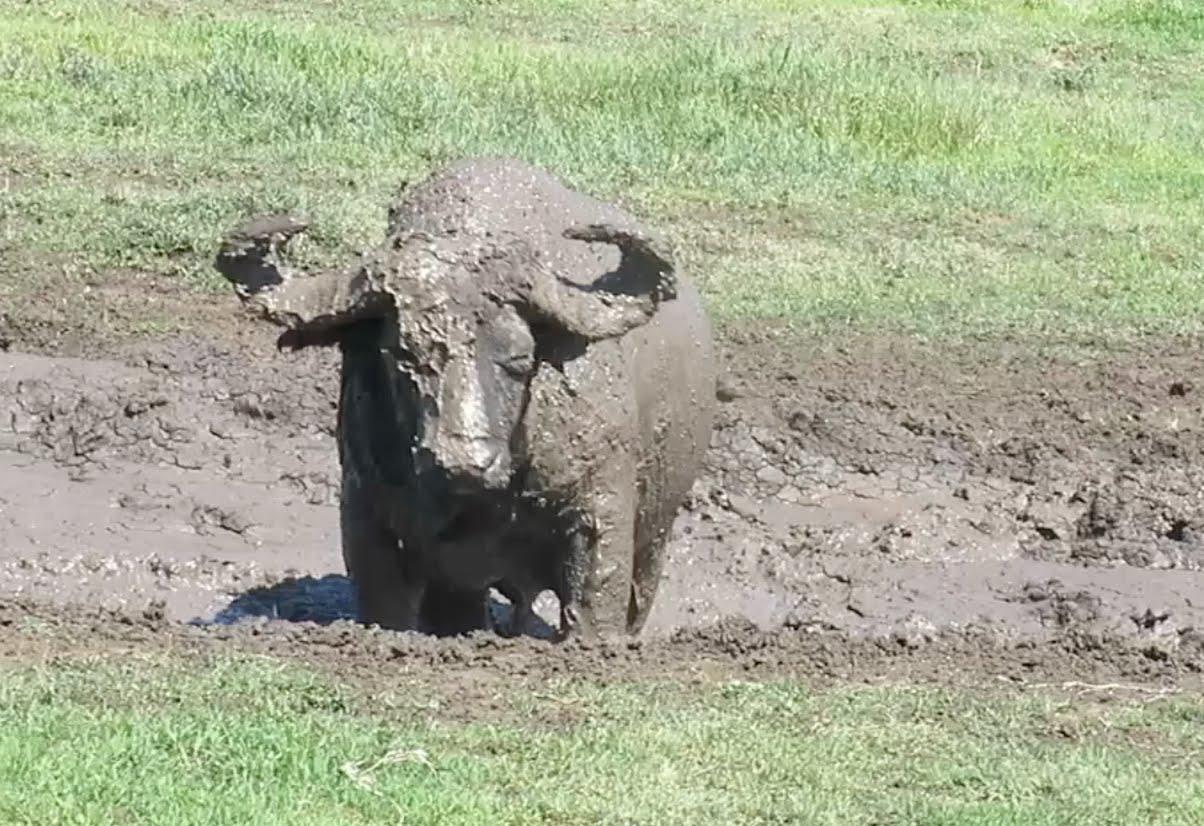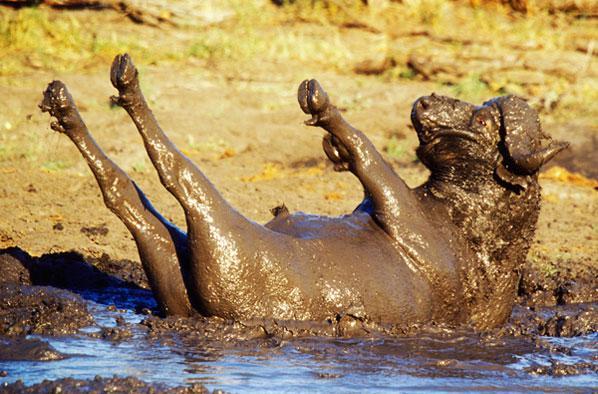The first image is the image on the left, the second image is the image on the right. Evaluate the accuracy of this statement regarding the images: "The right image shows a single bull rolling on its back with legs in the air, while the left image shows a single bull wading through mud.". Is it true? Answer yes or no. Yes. The first image is the image on the left, the second image is the image on the right. Assess this claim about the two images: "The right image shows one muddy water buffalo lying on its back with its hind legs extended up in the air.". Correct or not? Answer yes or no. Yes. 